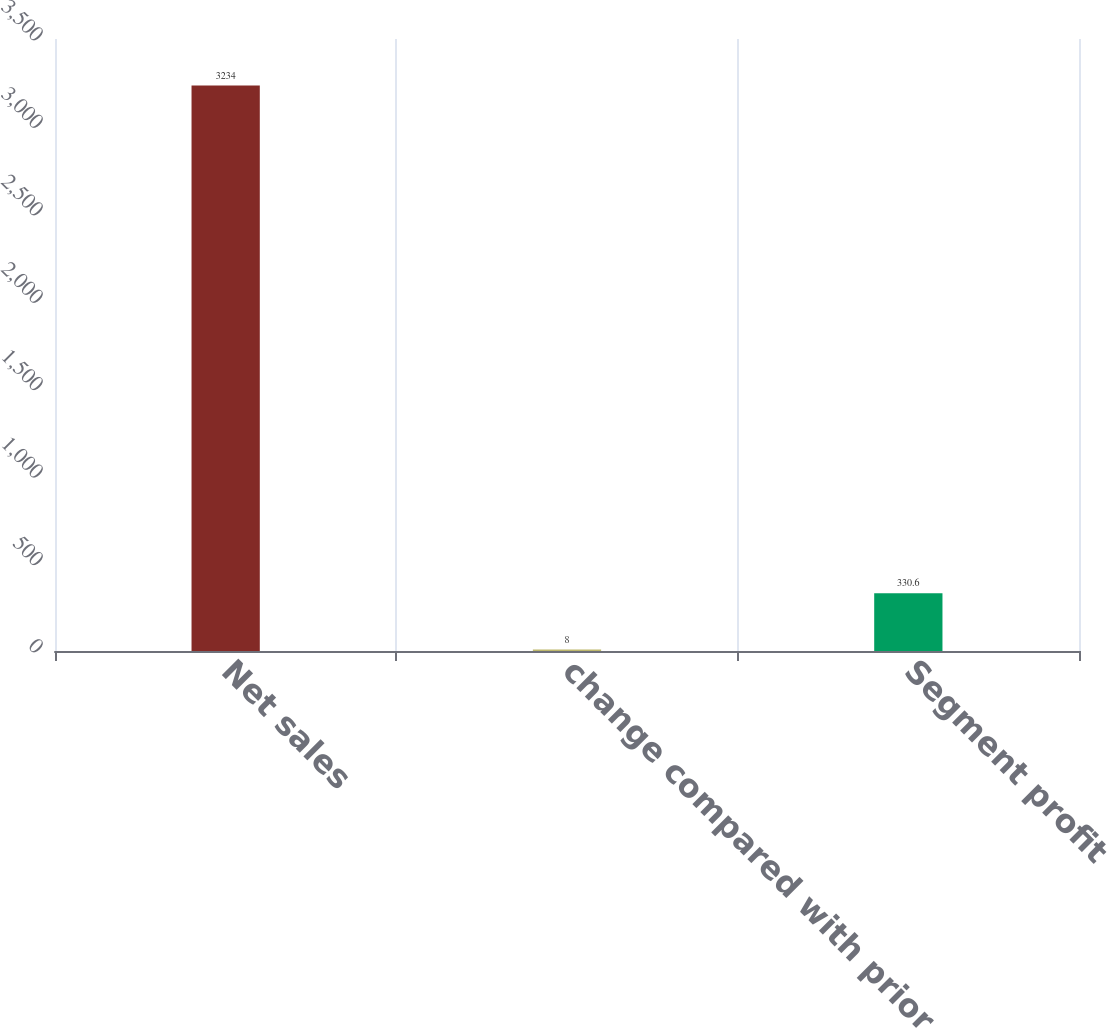Convert chart. <chart><loc_0><loc_0><loc_500><loc_500><bar_chart><fcel>Net sales<fcel>change compared with prior<fcel>Segment profit<nl><fcel>3234<fcel>8<fcel>330.6<nl></chart> 